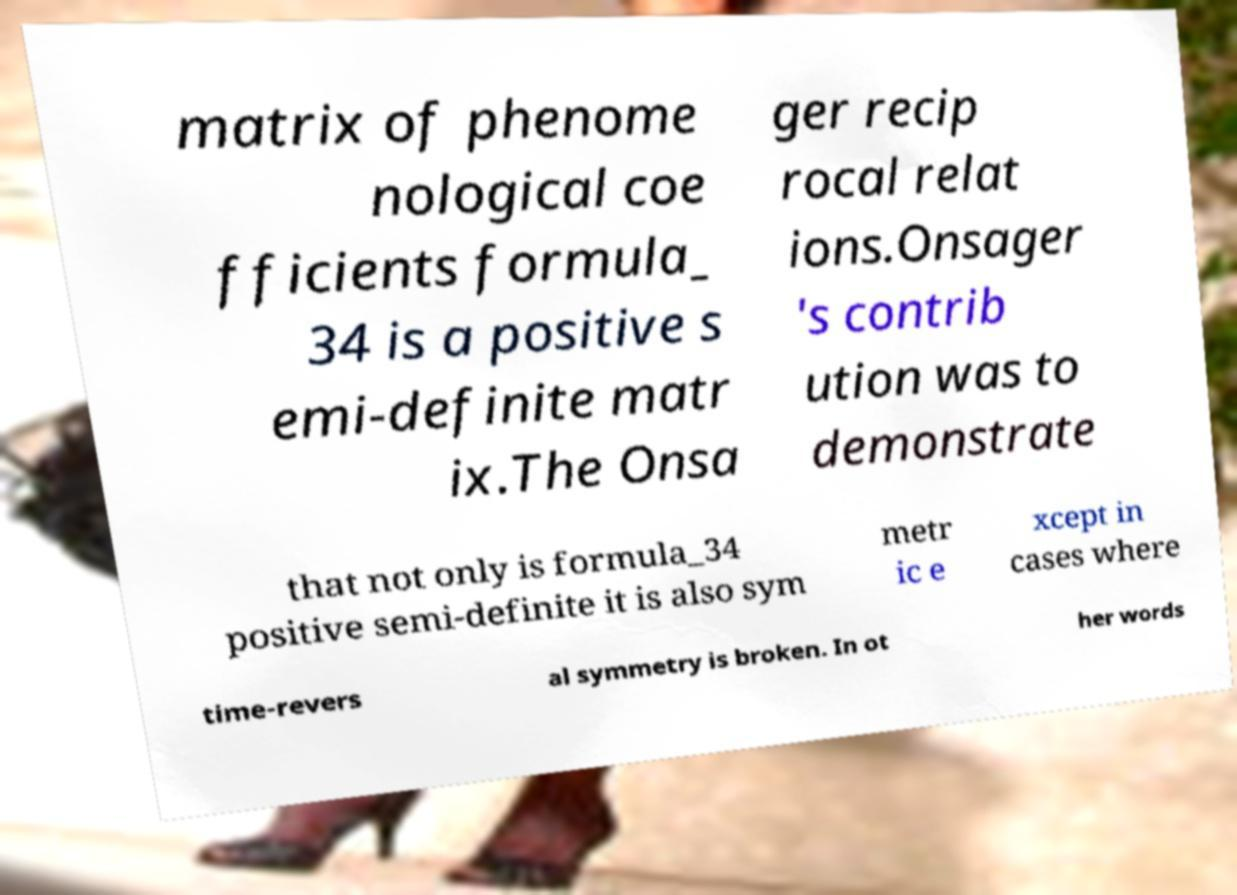Can you read and provide the text displayed in the image?This photo seems to have some interesting text. Can you extract and type it out for me? matrix of phenome nological coe fficients formula_ 34 is a positive s emi-definite matr ix.The Onsa ger recip rocal relat ions.Onsager 's contrib ution was to demonstrate that not only is formula_34 positive semi-definite it is also sym metr ic e xcept in cases where time-revers al symmetry is broken. In ot her words 